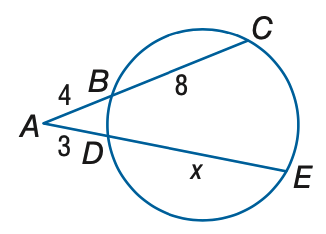Answer the mathemtical geometry problem and directly provide the correct option letter.
Question: Find x to the nearest tenth.
Choices: A: 10 B: 11 C: 12 D: 13 D 